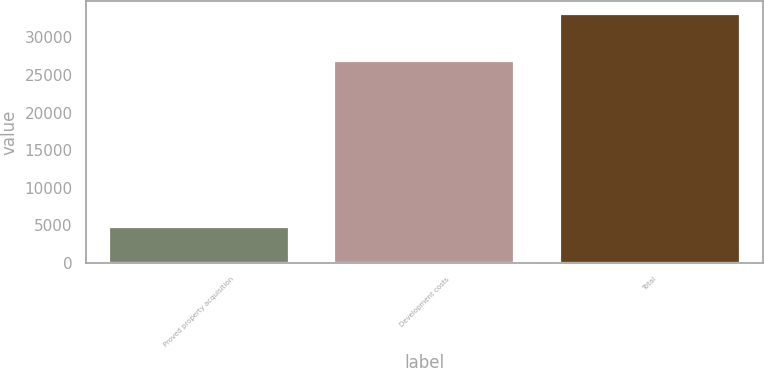<chart> <loc_0><loc_0><loc_500><loc_500><bar_chart><fcel>Proved property acquisition<fcel>Development costs<fcel>Total<nl><fcel>4750<fcel>26880<fcel>33129<nl></chart> 